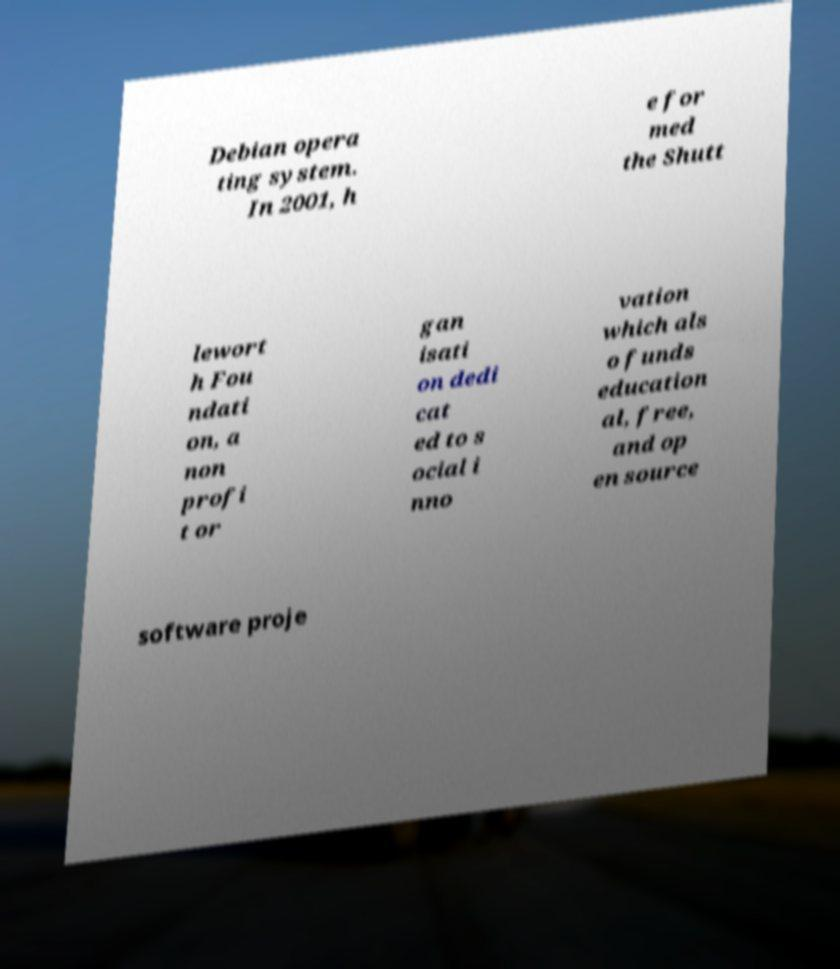For documentation purposes, I need the text within this image transcribed. Could you provide that? Debian opera ting system. In 2001, h e for med the Shutt lewort h Fou ndati on, a non profi t or gan isati on dedi cat ed to s ocial i nno vation which als o funds education al, free, and op en source software proje 